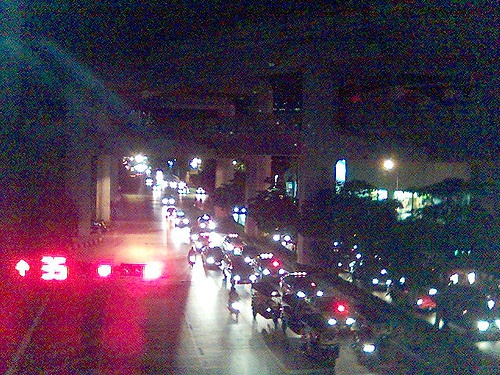Describe the objects in this image and their specific colors. I can see car in blue, gray, white, purple, and navy tones, car in blue, gray, purple, brown, and maroon tones, car in blue, gray, navy, and black tones, traffic light in blue, brown, magenta, white, and violet tones, and car in blue, purple, and white tones in this image. 